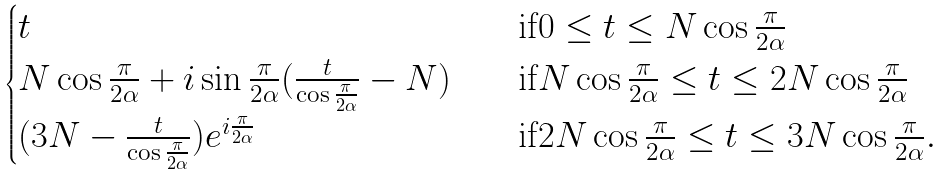Convert formula to latex. <formula><loc_0><loc_0><loc_500><loc_500>\begin{cases} t \quad & \text {if} 0 \leq t \leq N \cos \frac { \pi } { 2 \alpha } \\ N \cos \frac { \pi } { 2 \alpha } + i \sin \frac { \pi } { 2 \alpha } ( \frac { t } { \cos \frac { \pi } { 2 \alpha } } - N ) \quad & \text {if} N \cos \frac { \pi } { 2 \alpha } \leq t \leq 2 N \cos \frac { \pi } { 2 \alpha } \\ ( 3 N - \frac { t } { \cos \frac { \pi } { 2 \alpha } } ) e ^ { i \frac { \pi } { 2 \alpha } } \quad & \text {if} 2 N \cos \frac { \pi } { 2 \alpha } \leq t \leq 3 N \cos \frac { \pi } { 2 \alpha } . \end{cases}</formula> 